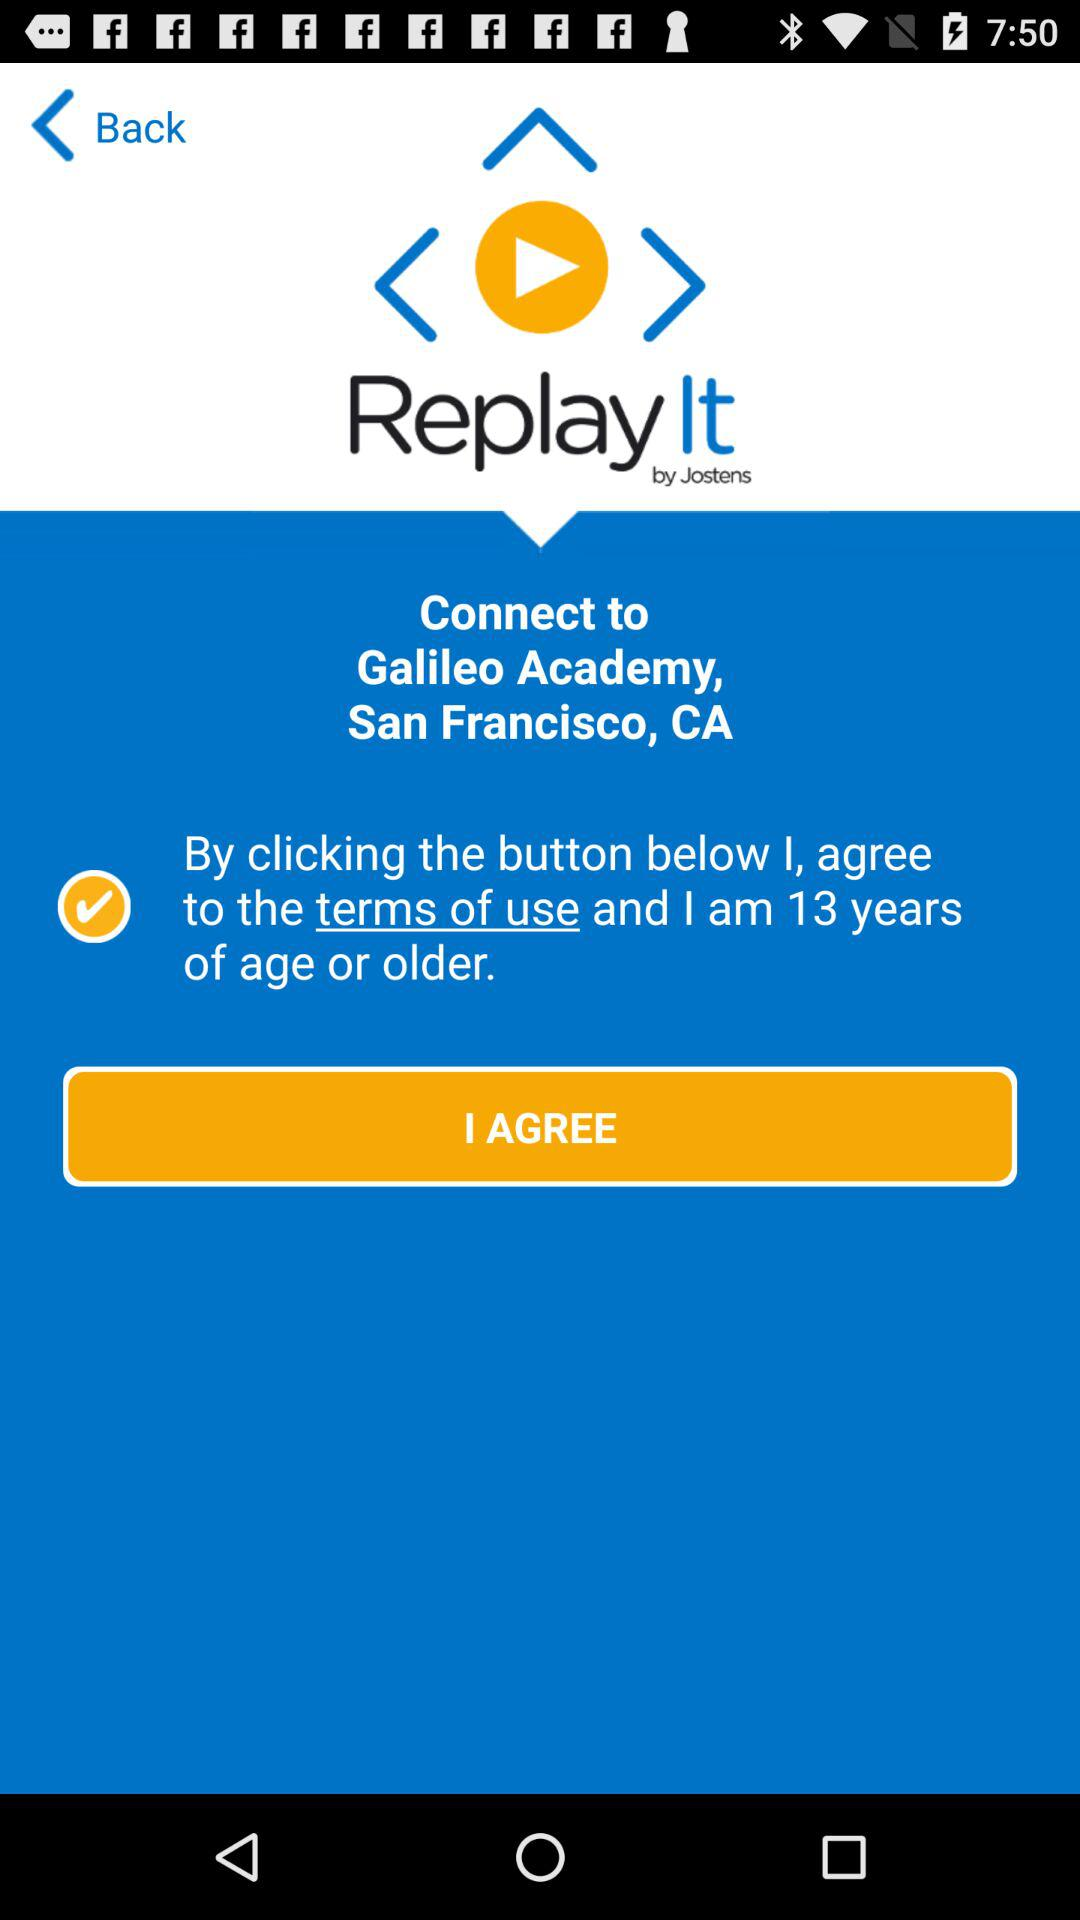How many years of age are required to agree to the terms of use?
Answer the question using a single word or phrase. 13 